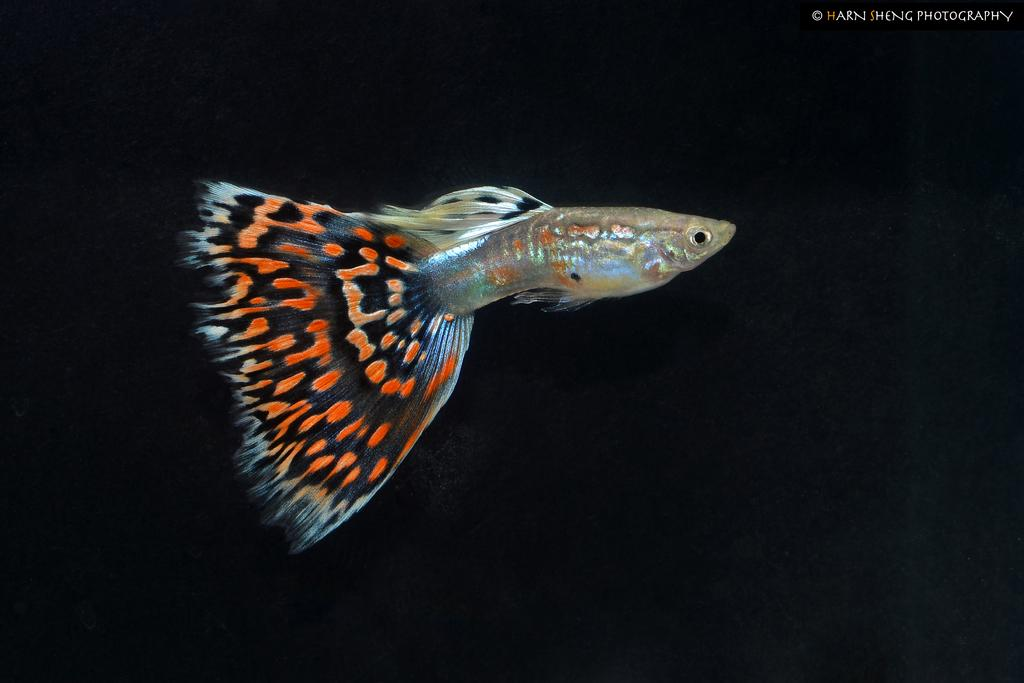What is the main subject of the picture? The main subject of the picture is a fish. Can you describe the colors of the fish? The fish has black and orange colors. What is the color of the background in the image? The background of the image is black. What type of relation does the fish have with the family in the image? There is no family present in the image, only a fish. How many questions can be seen in the image? There are no questions visible in the image, as it features a fish with a black and orange color scheme against a black background. 